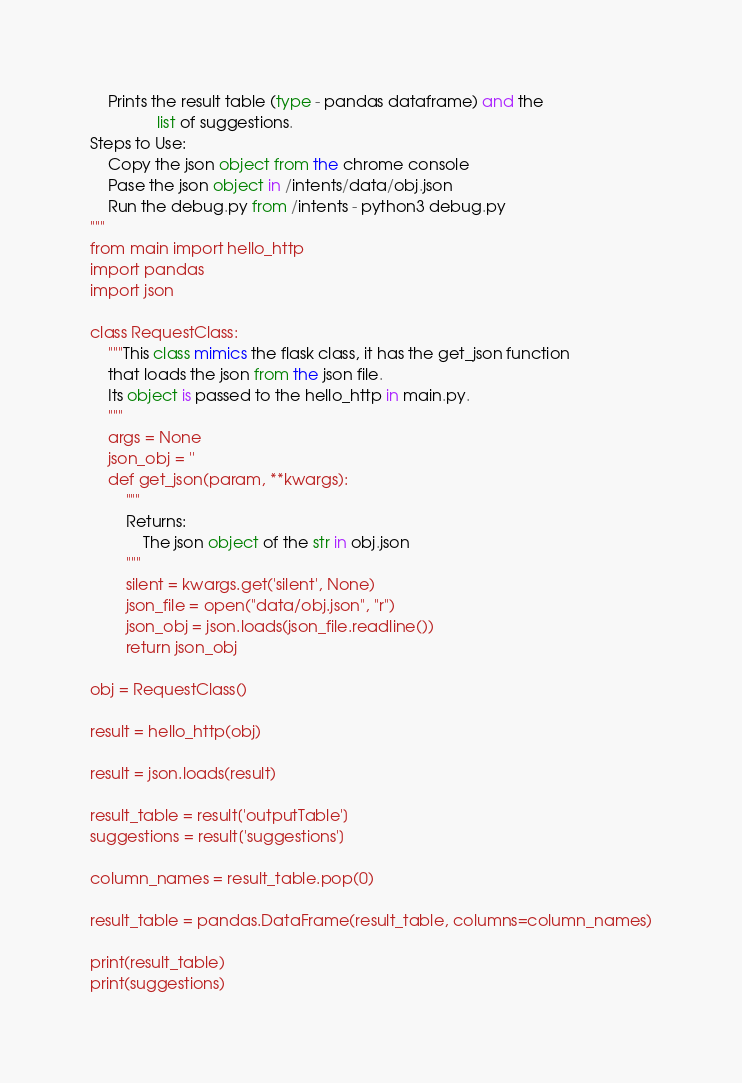<code> <loc_0><loc_0><loc_500><loc_500><_Python_>    Prints the result table (type - pandas dataframe) and the
               list of suggestions.
Steps to Use:
    Copy the json object from the chrome console
    Pase the json object in /intents/data/obj.json
    Run the debug.py from /intents - python3 debug.py
"""
from main import hello_http
import pandas
import json

class RequestClass:
    """This class mimics the flask class, it has the get_json function
    that loads the json from the json file.
    Its object is passed to the hello_http in main.py.
    """
    args = None
    json_obj = ''
    def get_json(param, **kwargs):
        """
        Returns:
            The json object of the str in obj.json
        """
        silent = kwargs.get('silent', None)
        json_file = open("data/obj.json", "r")
        json_obj = json.loads(json_file.readline())
        return json_obj

obj = RequestClass()

result = hello_http(obj)

result = json.loads(result)

result_table = result['outputTable']
suggestions = result['suggestions']

column_names = result_table.pop(0)

result_table = pandas.DataFrame(result_table, columns=column_names)

print(result_table)
print(suggestions)
</code> 